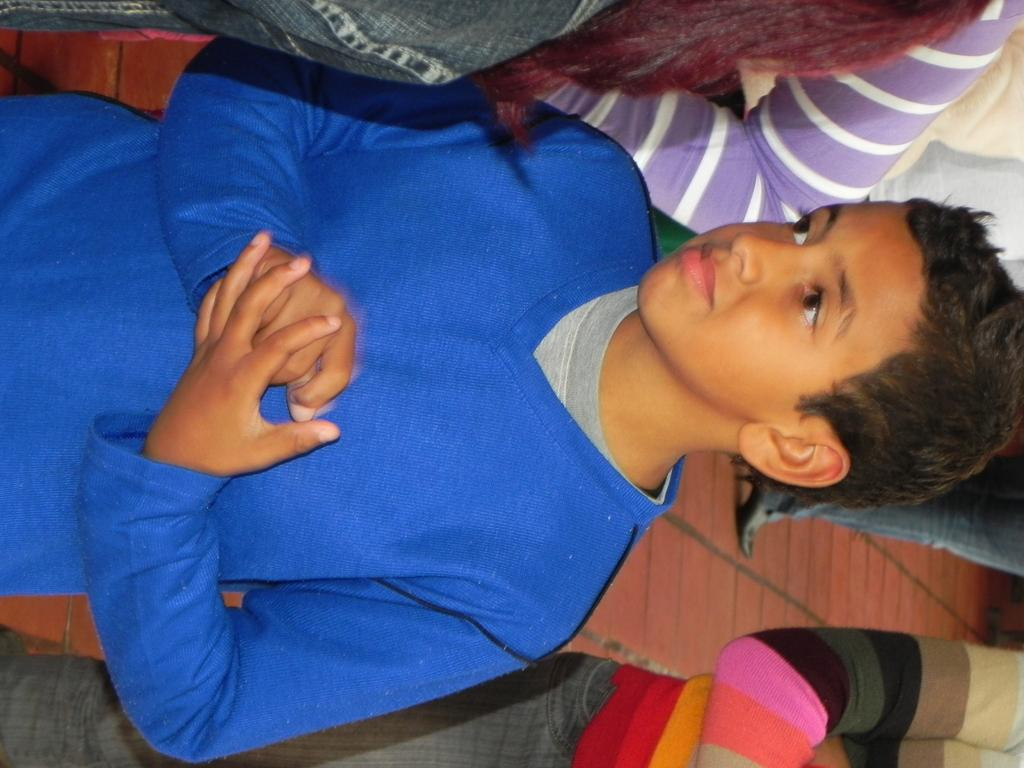Who or what can be seen in the image? There are people in the image. What type of flooring is present in the image? There is a wooden floor in the image. Can you describe the position of the boy in the image? A boy is standing in the front of the image. What color is the t-shirt worn by the boy? The boy is wearing a blue color t-shirt. Is the queen expressing regret in the image? There is no queen present in the image, so it is not possible to determine if she is expressing regret. 